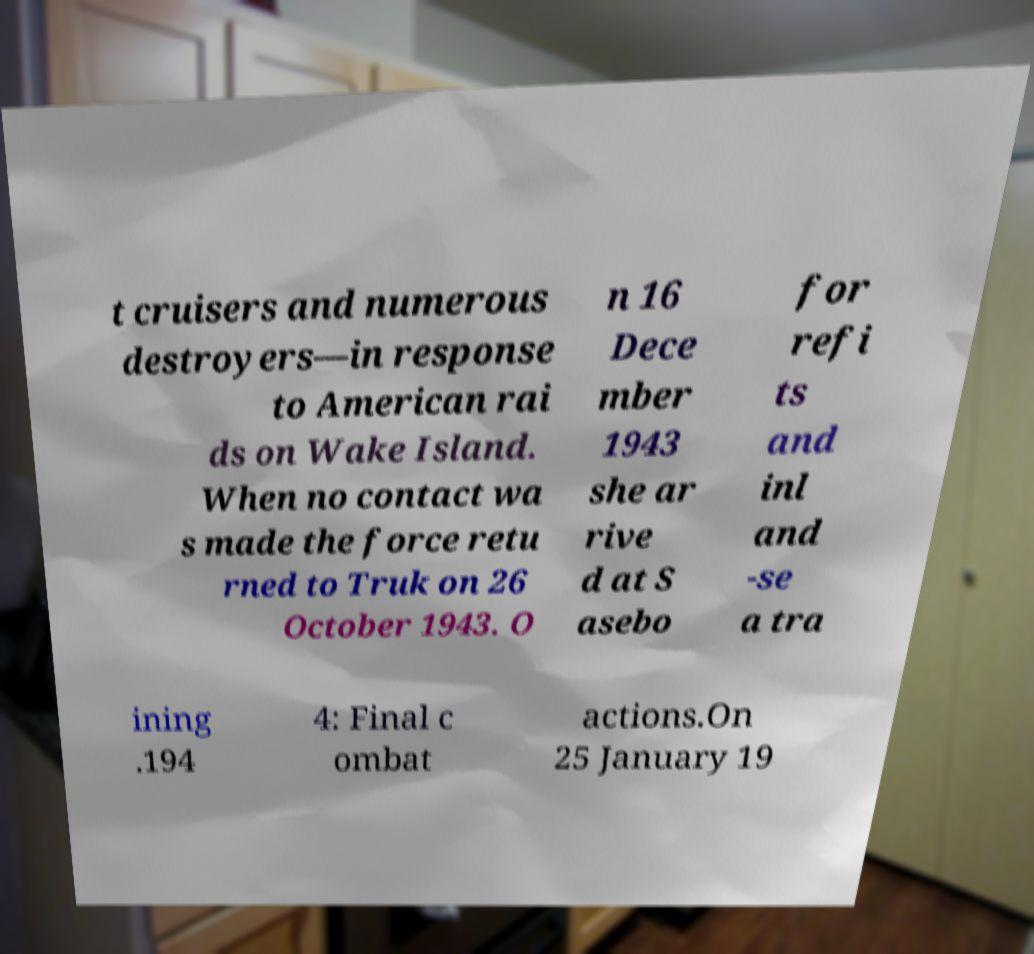Could you extract and type out the text from this image? t cruisers and numerous destroyers—in response to American rai ds on Wake Island. When no contact wa s made the force retu rned to Truk on 26 October 1943. O n 16 Dece mber 1943 she ar rive d at S asebo for refi ts and inl and -se a tra ining .194 4: Final c ombat actions.On 25 January 19 